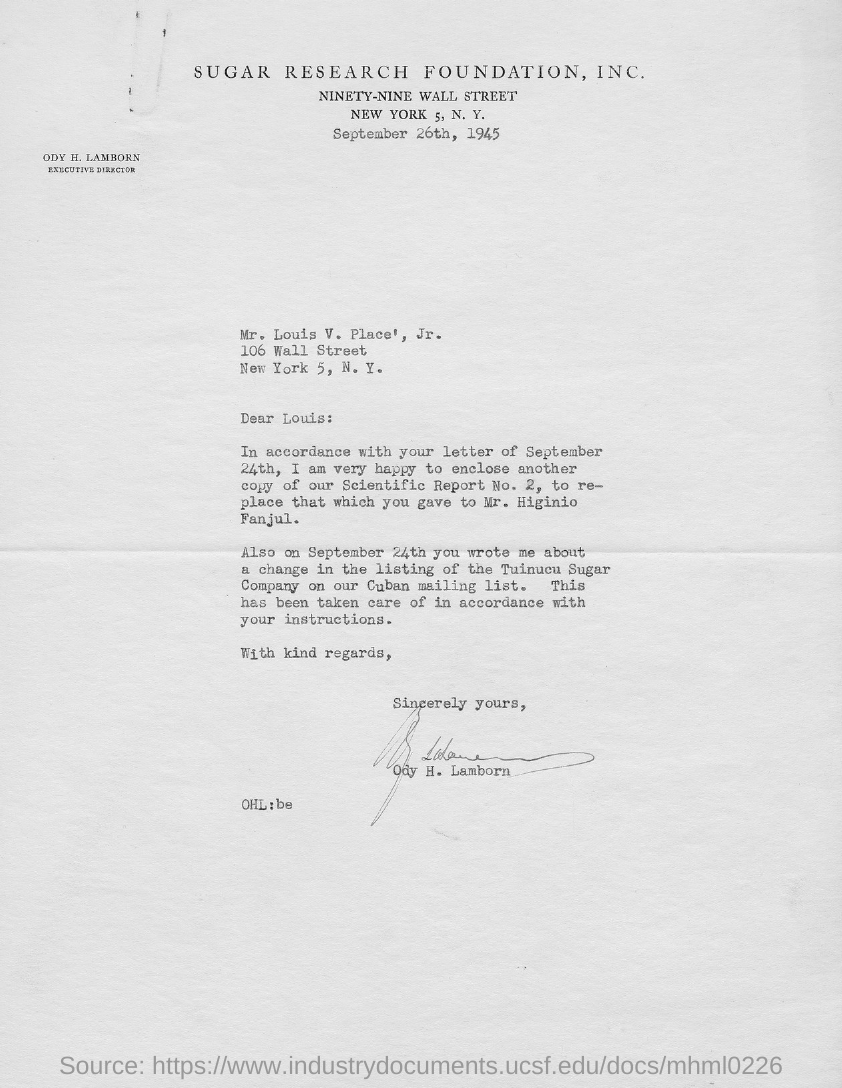Draw attention to some important aspects in this diagram. The letter is dated September 26th, 1945. It has been announced that Ody H. Lamborn holds the position of Executive Director. 